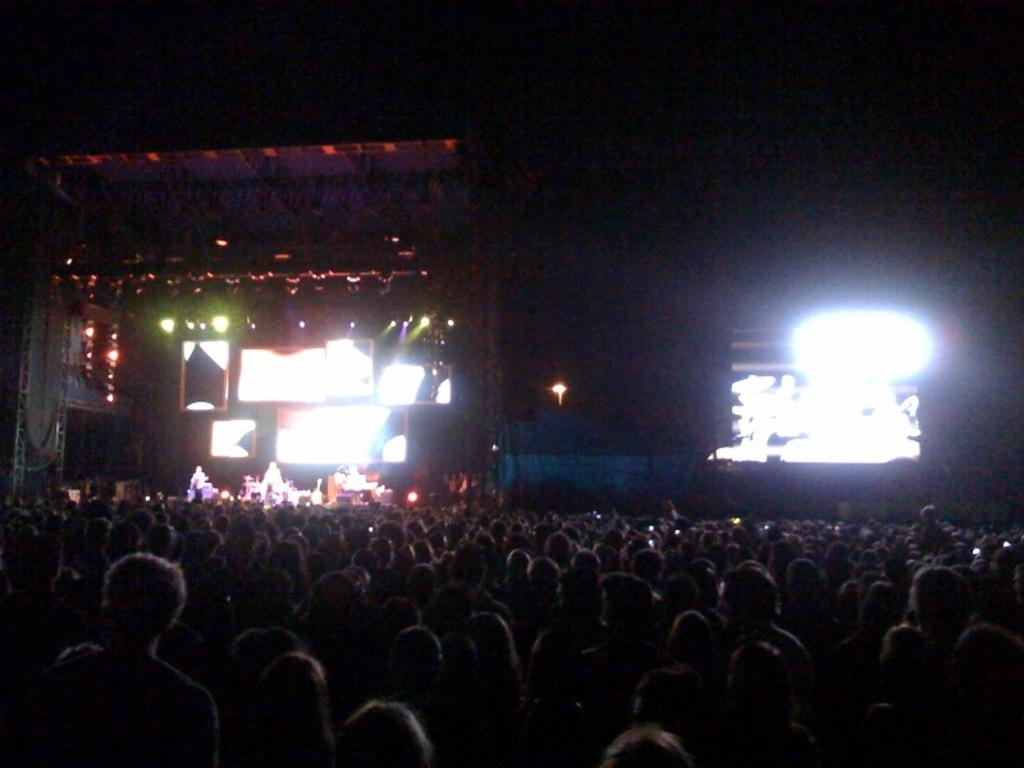What is the overall lighting condition in the image? The image is dark. How many people are in the image? There are multiple persons in the image. What is the main feature of the setting? There is a stage in the image. Are there any people on the stage? Yes, there are persons on the stage. What other elements can be seen in the image? There are screens and lights in the image. What is the color of the background in the image? The background of the image is dark. What type of sticks are being used by the persons in the image? There are no sticks visible in the image. What fact can be learned from the image about the front row of the audience? The image does not provide any information about the front row of the audience, as it focuses on the stage and the people on it. 